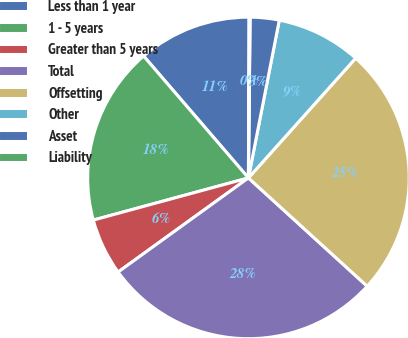<chart> <loc_0><loc_0><loc_500><loc_500><pie_chart><fcel>Less than 1 year<fcel>1 - 5 years<fcel>Greater than 5 years<fcel>Total<fcel>Offsetting<fcel>Other<fcel>Asset<fcel>Liability<nl><fcel>11.37%<fcel>17.92%<fcel>5.73%<fcel>28.28%<fcel>25.14%<fcel>8.55%<fcel>2.91%<fcel>0.1%<nl></chart> 